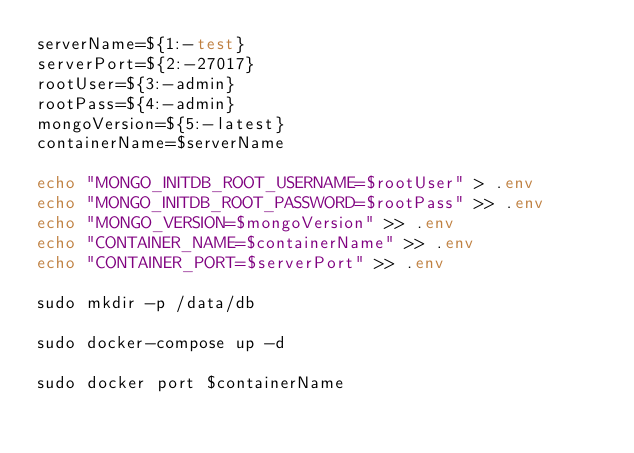<code> <loc_0><loc_0><loc_500><loc_500><_Bash_>serverName=${1:-test}
serverPort=${2:-27017}
rootUser=${3:-admin}
rootPass=${4:-admin}
mongoVersion=${5:-latest}
containerName=$serverName

echo "MONGO_INITDB_ROOT_USERNAME=$rootUser" > .env
echo "MONGO_INITDB_ROOT_PASSWORD=$rootPass" >> .env
echo "MONGO_VERSION=$mongoVersion" >> .env
echo "CONTAINER_NAME=$containerName" >> .env
echo "CONTAINER_PORT=$serverPort" >> .env

sudo mkdir -p /data/db

sudo docker-compose up -d

sudo docker port $containerName
</code> 